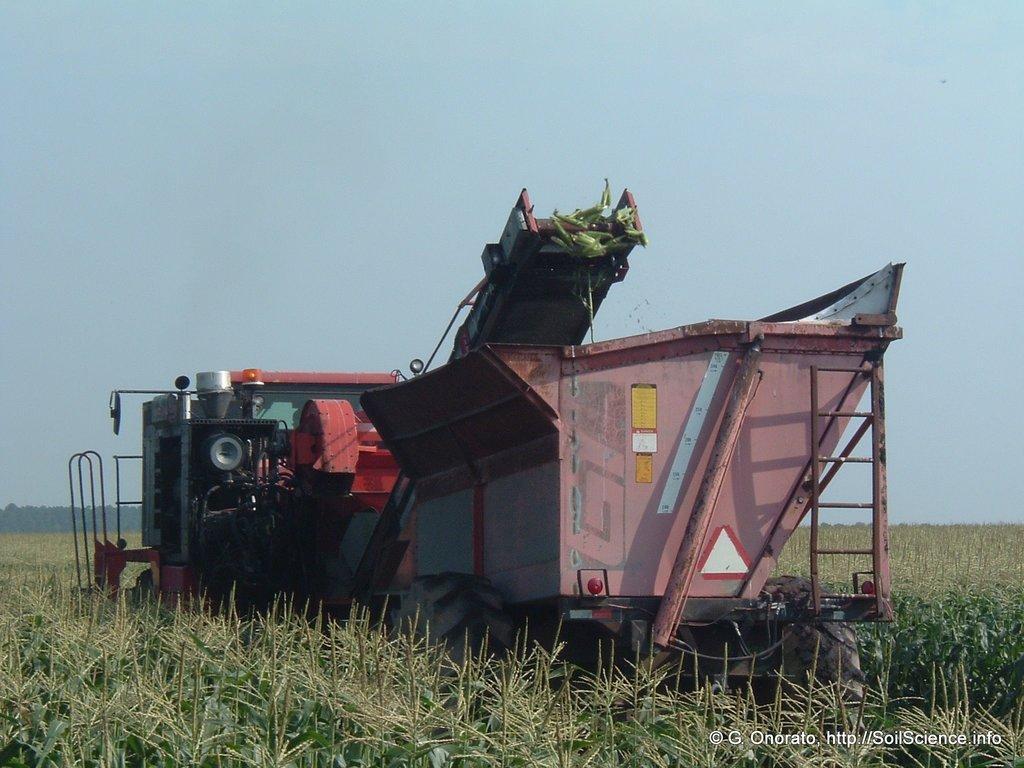In one or two sentences, can you explain what this image depicts? In this picture I can see many plants at the bottom, there is a machine at the center. There is the text in the bottom right hand side, at the top there is the sky. 